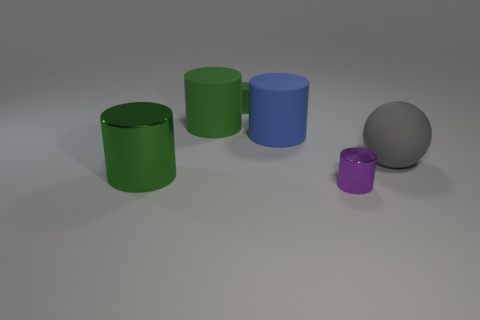How many green cylinders must be subtracted to get 1 green cylinders? 2 Subtract all brown balls. How many green cylinders are left? 3 Subtract 2 cylinders. How many cylinders are left? 3 Subtract all gray cylinders. Subtract all green spheres. How many cylinders are left? 5 Add 3 large blue matte cylinders. How many objects exist? 9 Subtract all balls. How many objects are left? 5 Subtract all red cylinders. Subtract all big gray balls. How many objects are left? 5 Add 2 small green rubber cylinders. How many small green rubber cylinders are left? 3 Add 5 big green shiny cylinders. How many big green shiny cylinders exist? 6 Subtract 0 gray cubes. How many objects are left? 6 